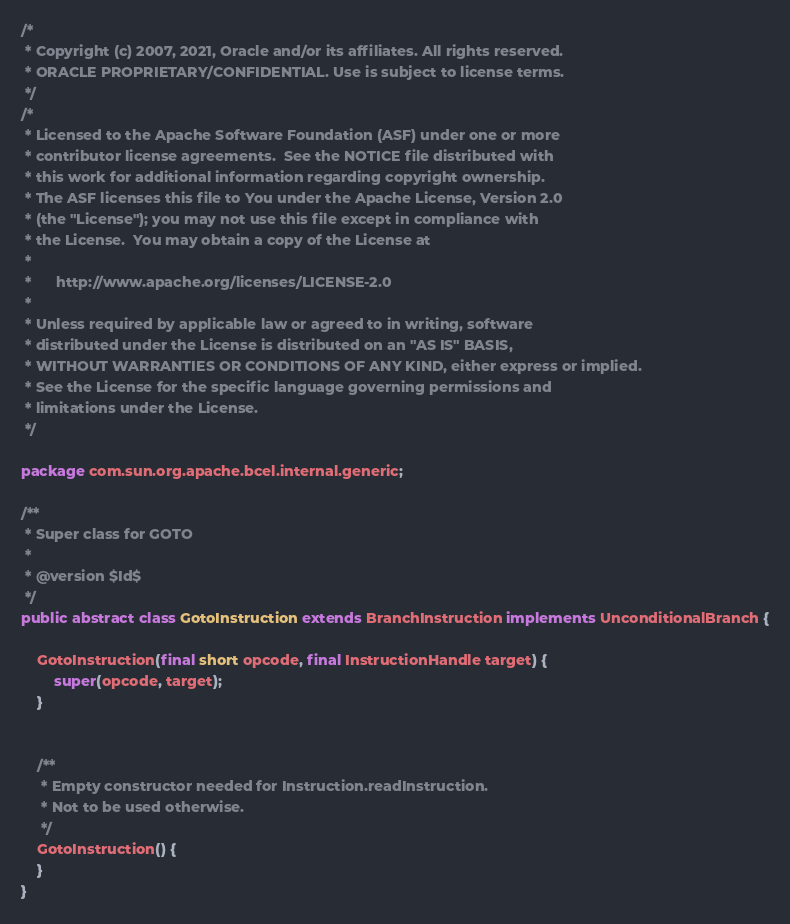<code> <loc_0><loc_0><loc_500><loc_500><_Java_>/*
 * Copyright (c) 2007, 2021, Oracle and/or its affiliates. All rights reserved.
 * ORACLE PROPRIETARY/CONFIDENTIAL. Use is subject to license terms.
 */
/*
 * Licensed to the Apache Software Foundation (ASF) under one or more
 * contributor license agreements.  See the NOTICE file distributed with
 * this work for additional information regarding copyright ownership.
 * The ASF licenses this file to You under the Apache License, Version 2.0
 * (the "License"); you may not use this file except in compliance with
 * the License.  You may obtain a copy of the License at
 *
 *      http://www.apache.org/licenses/LICENSE-2.0
 *
 * Unless required by applicable law or agreed to in writing, software
 * distributed under the License is distributed on an "AS IS" BASIS,
 * WITHOUT WARRANTIES OR CONDITIONS OF ANY KIND, either express or implied.
 * See the License for the specific language governing permissions and
 * limitations under the License.
 */

package com.sun.org.apache.bcel.internal.generic;

/**
 * Super class for GOTO
 *
 * @version $Id$
 */
public abstract class GotoInstruction extends BranchInstruction implements UnconditionalBranch {

    GotoInstruction(final short opcode, final InstructionHandle target) {
        super(opcode, target);
    }


    /**
     * Empty constructor needed for Instruction.readInstruction.
     * Not to be used otherwise.
     */
    GotoInstruction() {
    }
}
</code> 